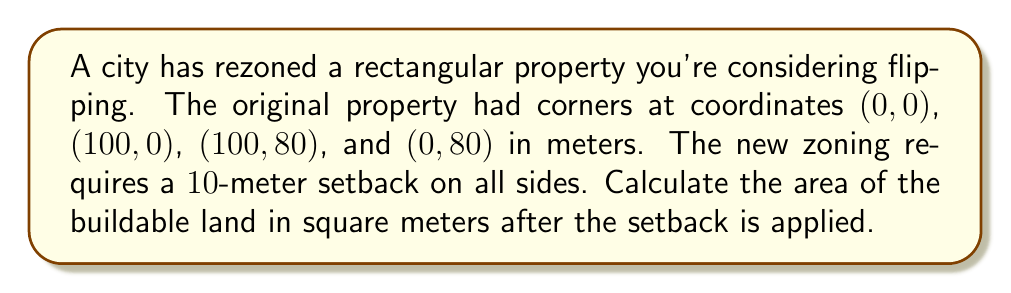Can you solve this math problem? Let's approach this step-by-step:

1) First, we need to determine the new coordinates of the buildable area after the setback:
   - The bottom-left corner moves from (0,0) to (10,10)
   - The top-right corner moves from (100,80) to (90,70)

2) Now we have a new rectangle with corners at (10,10), (90,10), (90,70), and (10,70).

3) To calculate the area of a rectangle, we use the formula:
   $$ A = l \times w $$
   where $A$ is area, $l$ is length, and $w$ is width.

4) Let's calculate the new dimensions:
   - Length: $90 - 10 = 80$ meters
   - Width: $70 - 10 = 60$ meters

5) Now we can calculate the area:
   $$ A = 80 \times 60 = 4800 \text{ square meters} $$

6) To verify, we can also calculate the original area and subtract the area lost to setbacks:
   - Original area: $100 \times 80 = 8000 \text{ sq m}$
   - Area lost:
     - Top and bottom: $100 \times 10 \times 2 = 2000 \text{ sq m}$
     - Left and right: $80 \times 10 \times 2 = 1600 \text{ sq m}$
     - Corners are double-counted, so add back: $10 \times 10 \times 4 = 400 \text{ sq m}$
   - Total area lost: $2000 + 1600 - 400 = 3200 \text{ sq m}$
   - Buildable area: $8000 - 3200 = 4800 \text{ sq m}$

This confirms our initial calculation.
Answer: 4800 square meters 